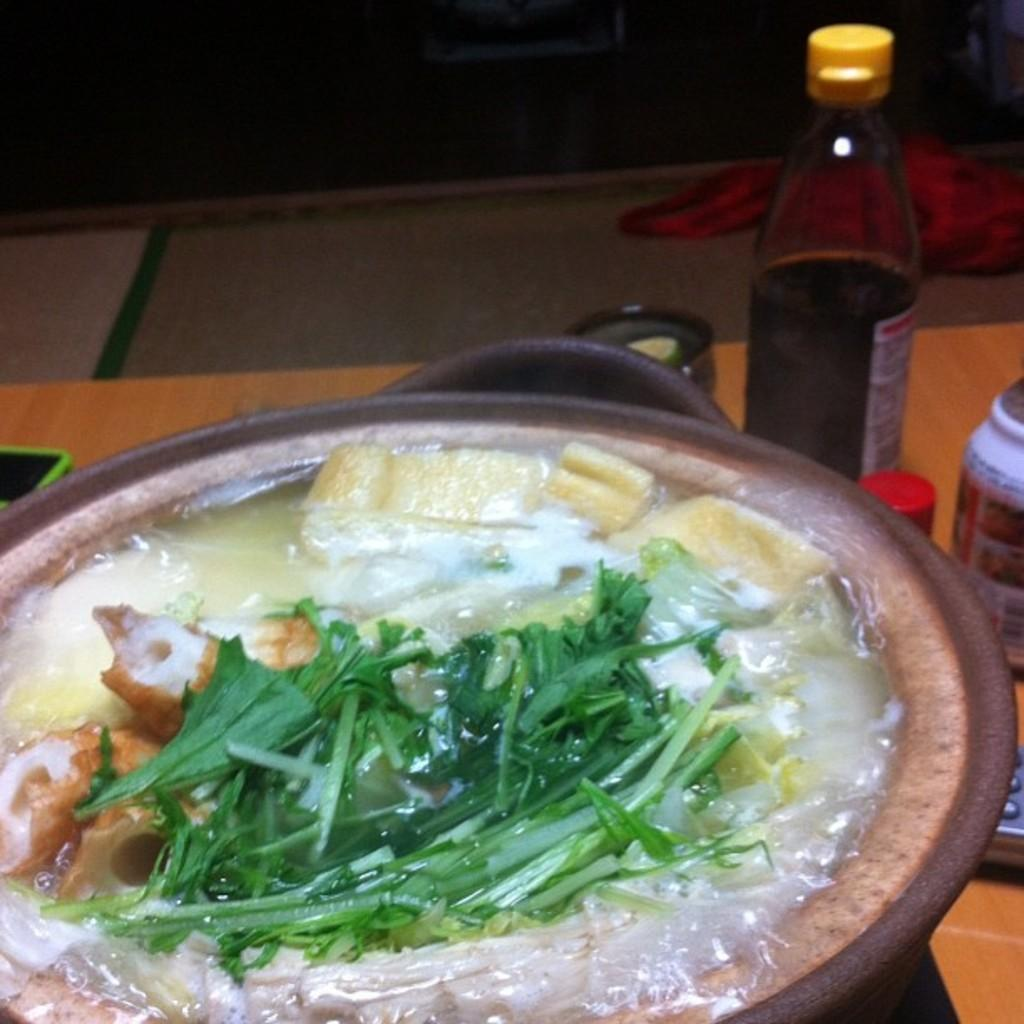What is the main object in the image? There is a vessel in the image. What is happening to the contents of the vessel? Water is being boiled in the vessel. What else can be seen near the vessel? There are sauce bottles and other ingredients beside the vessel. Is there a fireman present in the image? No, there is no fireman present in the image. What do you believe the other ingredients are used for in the image? The provided facts do not mention the specific ingredients or their purpose, so it cannot be determined from the image. 